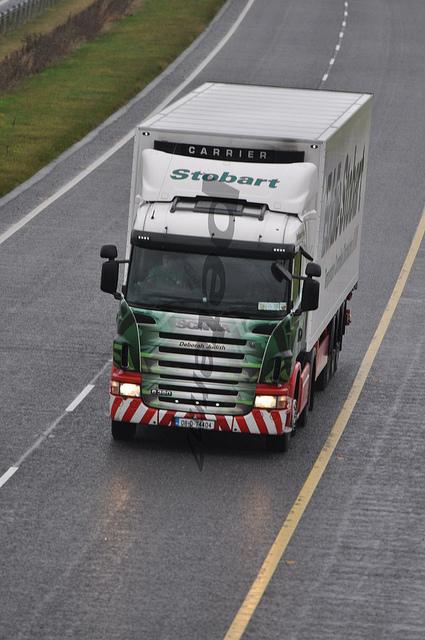Are the truck's front lights on?
Quick response, please. Yes. What does the front of the truck say in green?
Give a very brief answer. Stobart. How many vehicles are there?
Concise answer only. 1. Is the truck on the road?
Concise answer only. Yes. 